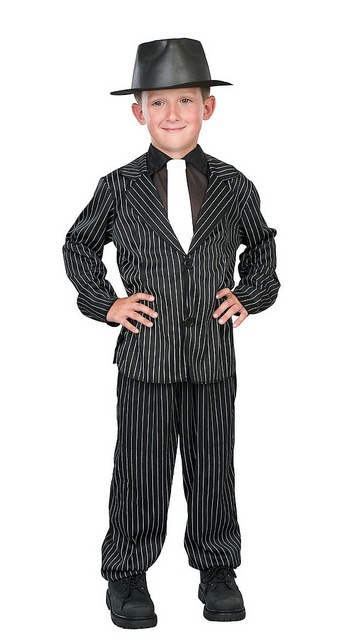Describe the objects in this image and their specific colors. I can see people in white, black, gray, darkgray, and lightpink tones and tie in white, gray, and darkgray tones in this image. 